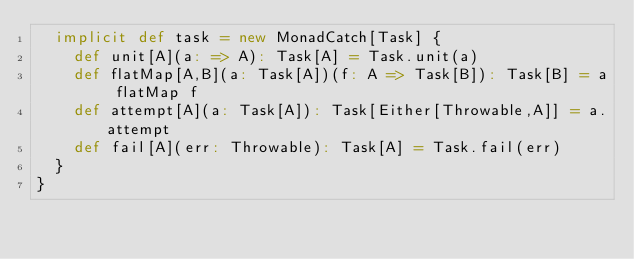<code> <loc_0><loc_0><loc_500><loc_500><_Scala_>  implicit def task = new MonadCatch[Task] {
    def unit[A](a: => A): Task[A] = Task.unit(a)
    def flatMap[A,B](a: Task[A])(f: A => Task[B]): Task[B] = a flatMap f
    def attempt[A](a: Task[A]): Task[Either[Throwable,A]] = a.attempt
    def fail[A](err: Throwable): Task[A] = Task.fail(err)
  }
}
</code> 